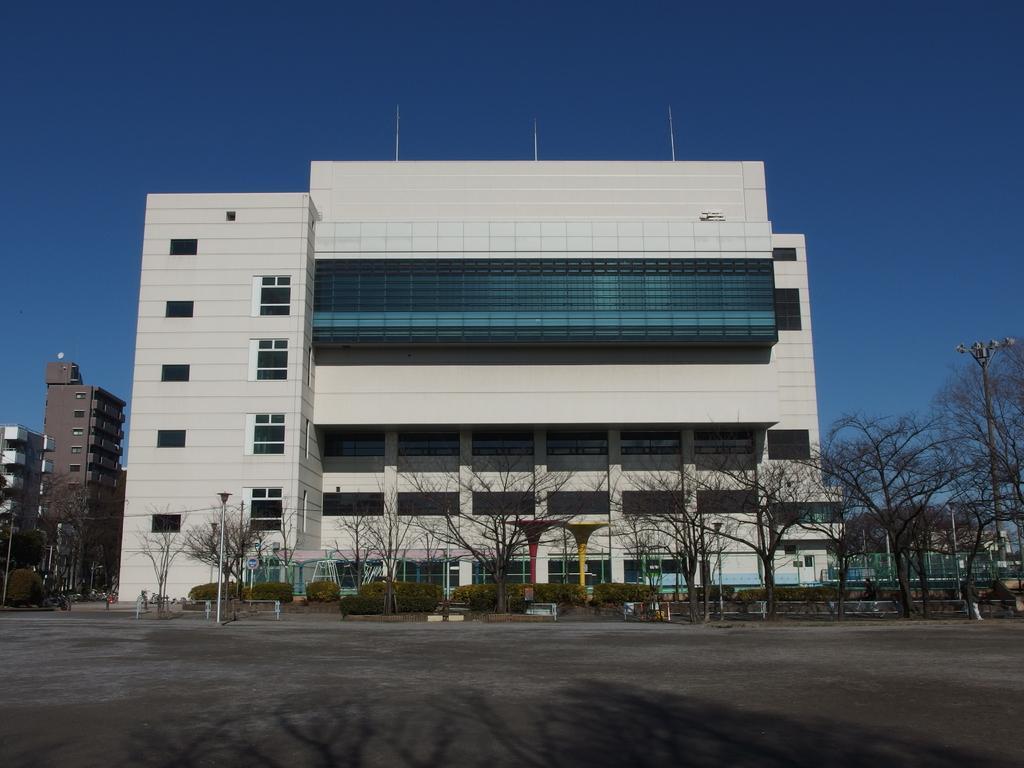In one or two sentences, can you explain what this image depicts? In this image we can see buildings, trees, plants, street light and road in front of the building and a sky in the background. 